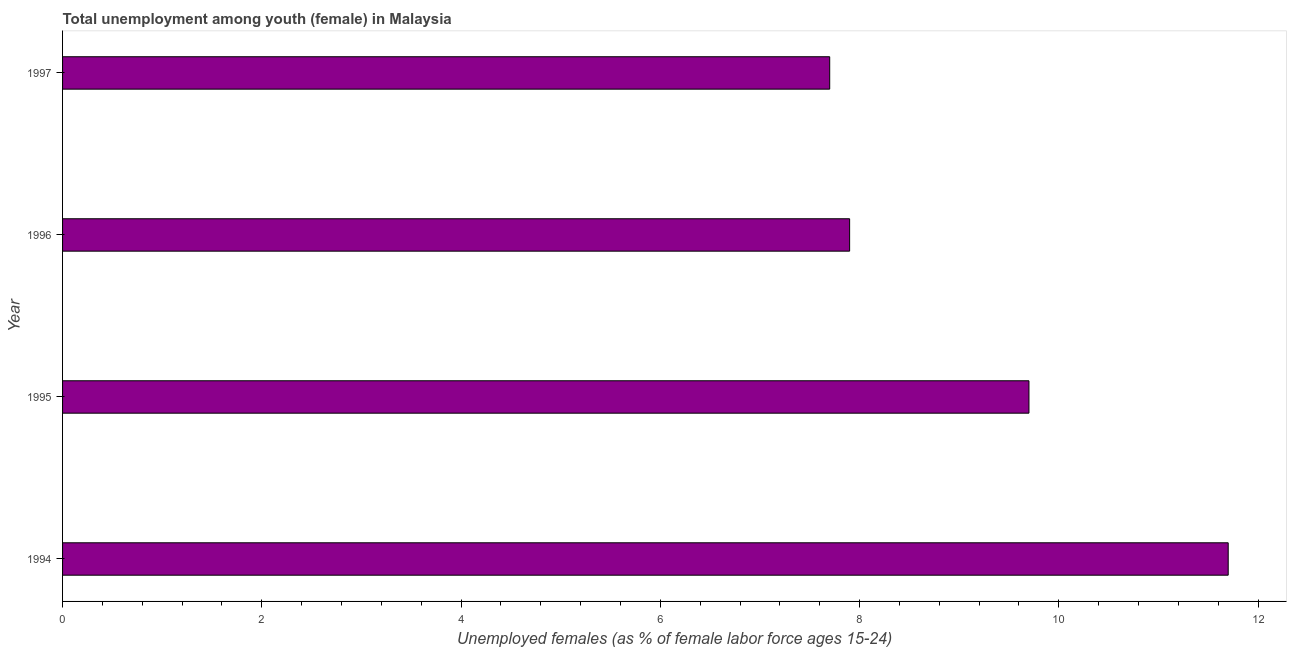Does the graph contain grids?
Your answer should be very brief. No. What is the title of the graph?
Ensure brevity in your answer.  Total unemployment among youth (female) in Malaysia. What is the label or title of the X-axis?
Keep it short and to the point. Unemployed females (as % of female labor force ages 15-24). What is the label or title of the Y-axis?
Make the answer very short. Year. What is the unemployed female youth population in 1995?
Your answer should be compact. 9.7. Across all years, what is the maximum unemployed female youth population?
Provide a short and direct response. 11.7. Across all years, what is the minimum unemployed female youth population?
Offer a terse response. 7.7. In which year was the unemployed female youth population minimum?
Make the answer very short. 1997. What is the sum of the unemployed female youth population?
Ensure brevity in your answer.  37. What is the difference between the unemployed female youth population in 1994 and 1995?
Your answer should be very brief. 2. What is the average unemployed female youth population per year?
Give a very brief answer. 9.25. What is the median unemployed female youth population?
Your response must be concise. 8.8. What is the ratio of the unemployed female youth population in 1995 to that in 1997?
Offer a terse response. 1.26. Are the values on the major ticks of X-axis written in scientific E-notation?
Your answer should be compact. No. What is the Unemployed females (as % of female labor force ages 15-24) of 1994?
Ensure brevity in your answer.  11.7. What is the Unemployed females (as % of female labor force ages 15-24) of 1995?
Give a very brief answer. 9.7. What is the Unemployed females (as % of female labor force ages 15-24) in 1996?
Offer a very short reply. 7.9. What is the Unemployed females (as % of female labor force ages 15-24) of 1997?
Provide a short and direct response. 7.7. What is the difference between the Unemployed females (as % of female labor force ages 15-24) in 1995 and 1997?
Provide a short and direct response. 2. What is the difference between the Unemployed females (as % of female labor force ages 15-24) in 1996 and 1997?
Provide a succinct answer. 0.2. What is the ratio of the Unemployed females (as % of female labor force ages 15-24) in 1994 to that in 1995?
Provide a short and direct response. 1.21. What is the ratio of the Unemployed females (as % of female labor force ages 15-24) in 1994 to that in 1996?
Your response must be concise. 1.48. What is the ratio of the Unemployed females (as % of female labor force ages 15-24) in 1994 to that in 1997?
Give a very brief answer. 1.52. What is the ratio of the Unemployed females (as % of female labor force ages 15-24) in 1995 to that in 1996?
Ensure brevity in your answer.  1.23. What is the ratio of the Unemployed females (as % of female labor force ages 15-24) in 1995 to that in 1997?
Offer a terse response. 1.26. 